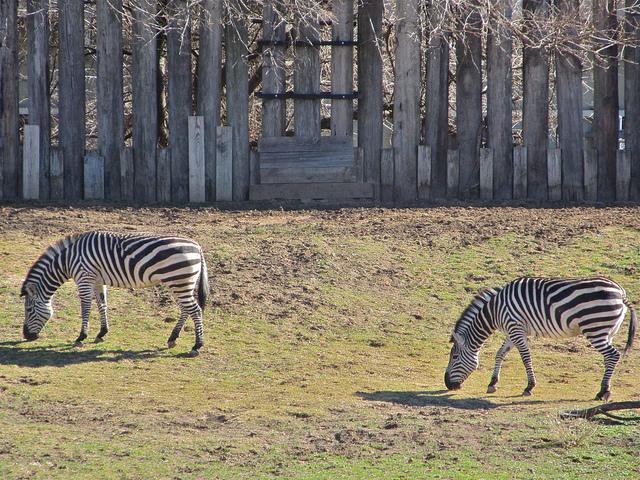What is in the background?
Quick response, please. Fence. Are these zebras in captivity?
Be succinct. Yes. Is this in the wild?
Write a very short answer. No. Are the zebras facing the same way?
Concise answer only. Yes. Are the zebras in a zoo?
Be succinct. Yes. 